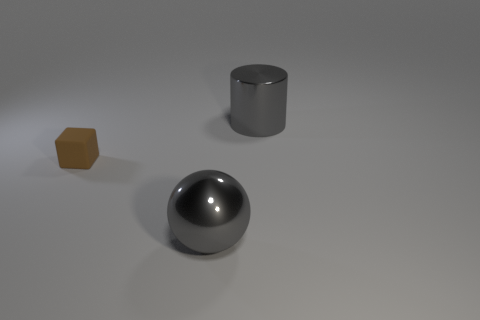Add 1 big brown cylinders. How many objects exist? 4 Subtract all cylinders. How many objects are left? 2 Add 3 metallic things. How many metallic things are left? 5 Add 3 big cylinders. How many big cylinders exist? 4 Subtract 0 gray cubes. How many objects are left? 3 Subtract all small objects. Subtract all big gray metallic things. How many objects are left? 0 